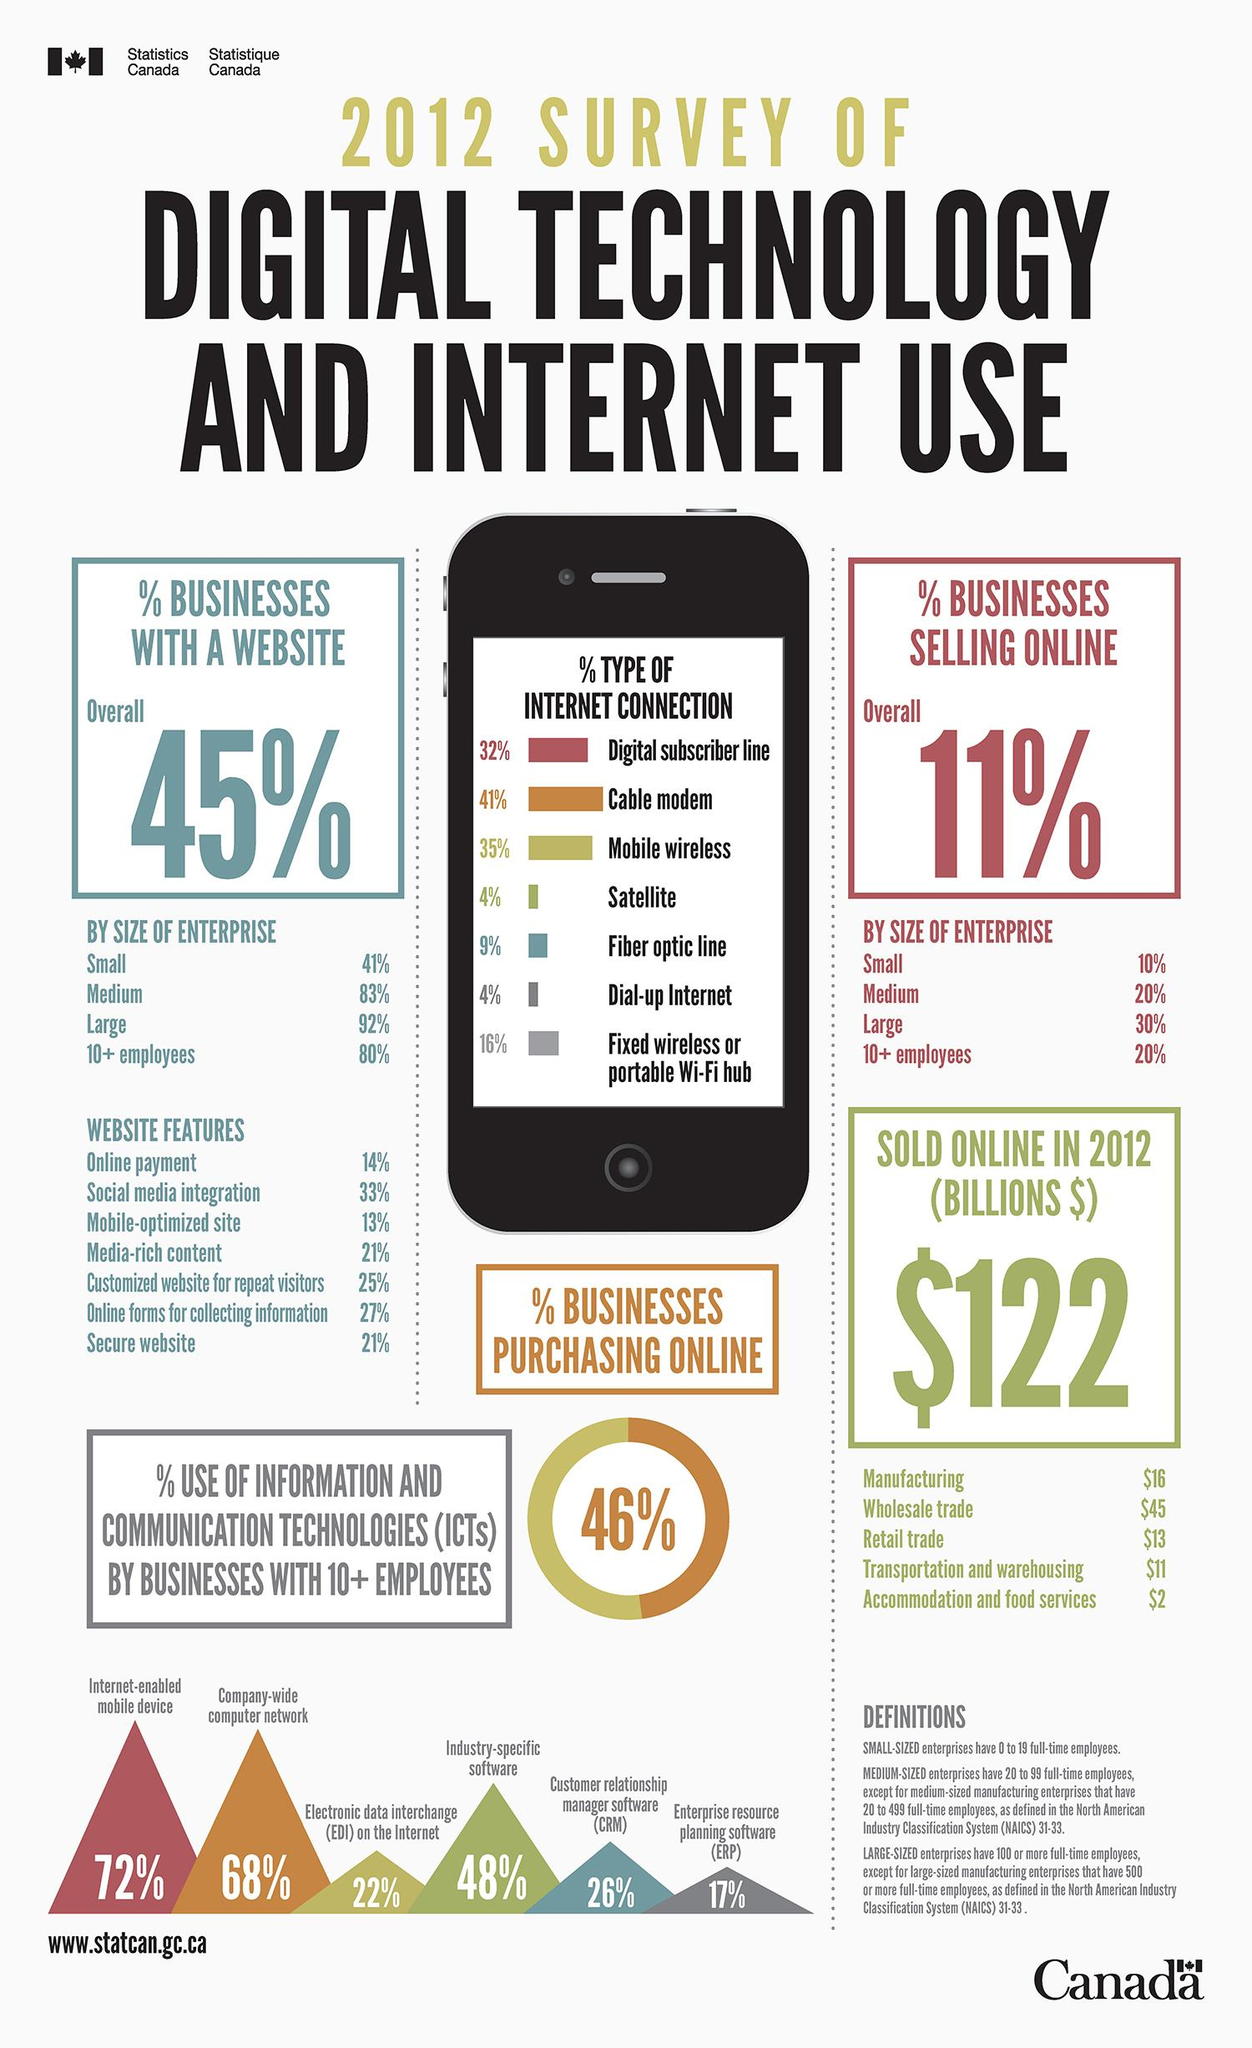Mention a couple of crucial points in this snapshot. According to the 2012 survey, 48% of businesses with 10+ employees in Canada use industry-specific software. According to a survey conducted in Canada in 2012, 21% of businesses had media-rich content in their websites. According to a 2012 survey, approximately 20% of medium-scale enterprises in Canada reported that a significant portion of their sales were generated through online business. According to a 2012 survey in Canada, mobile wireless type internet connections were used by businesses at a rate of 35%. According to a 2012 survey, approximately 17% of businesses with 10 or more employees in Canada use ERP software. 